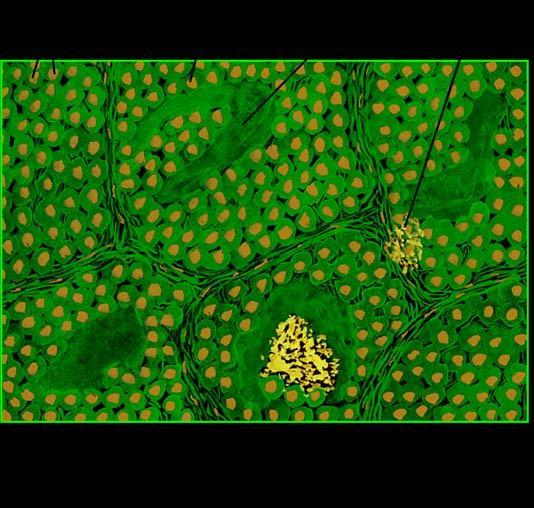what does amyloid show?
Answer the question using a single word or phrase. Congophilia which depicts apple-green birefringence under polarising microscopy 